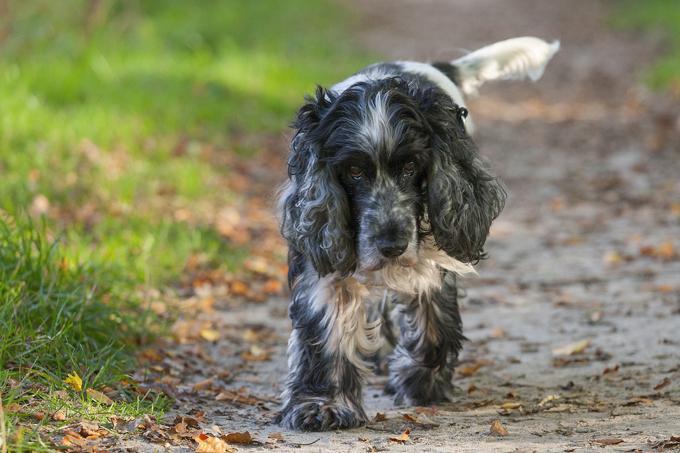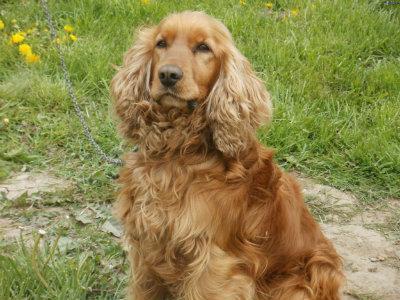The first image is the image on the left, the second image is the image on the right. Considering the images on both sides, is "At least two dogs are sitting int he grass." valid? Answer yes or no. No. The first image is the image on the left, the second image is the image on the right. Given the left and right images, does the statement "An image includes a white dog with black ears, and includes more than one dog." hold true? Answer yes or no. No. 